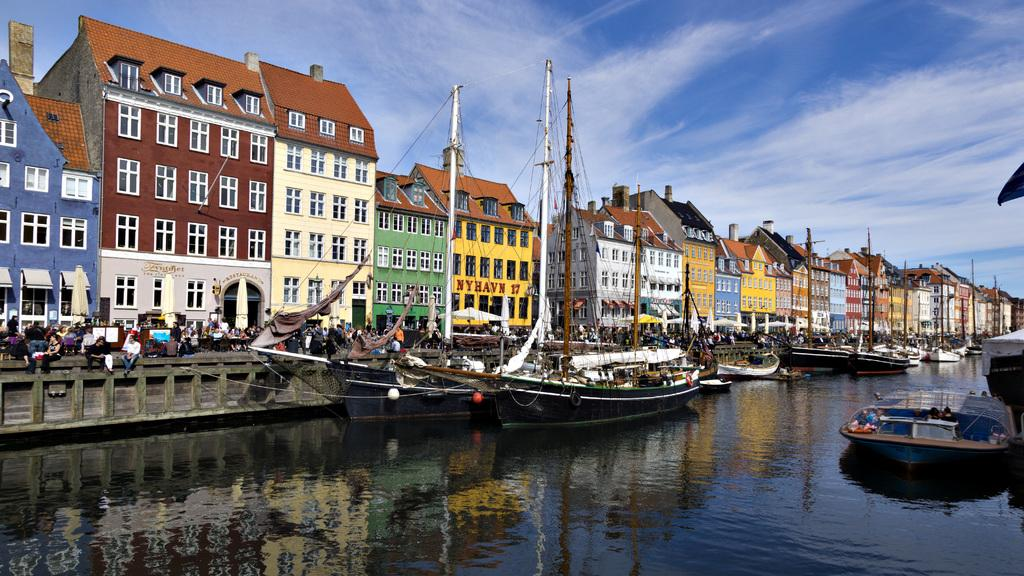What is located at the bottom of the image? There is a canal at the bottom of the image. What is in the canal? There are boats in the canal. What can be seen in the center of the image? There are buildings in the center of the image. What else is visible in the image? There are poles visible in the image. What is visible at the top of the image? The sky is visible at the top of the image. How many people are present in the image? There are many people standing in the image. What type of cork can be seen floating in the canal? There is no cork present in the image; it features a canal with boats. How does the honey affect the people standing in the image? There is no honey present in the image, so it cannot affect the people standing in the image. 